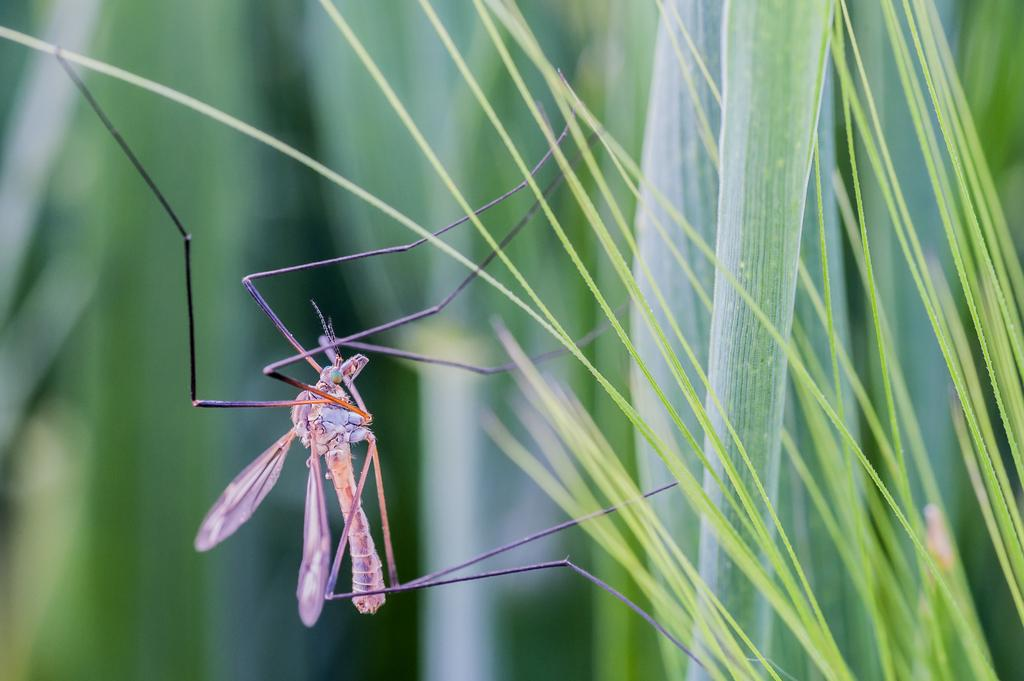What type of creature can be seen in the image? There is an insect in the image. Where is the insect located? The insect is on the grass. What is the color of the grass? The grass is green in color. How many trucks are parked on the grass in the image? There are no trucks present in the image; it features an insect on the grass. What type of unit is being measured by the insect in the image? There is no unit being measured by the insect in the image; it is simply on the grass. 